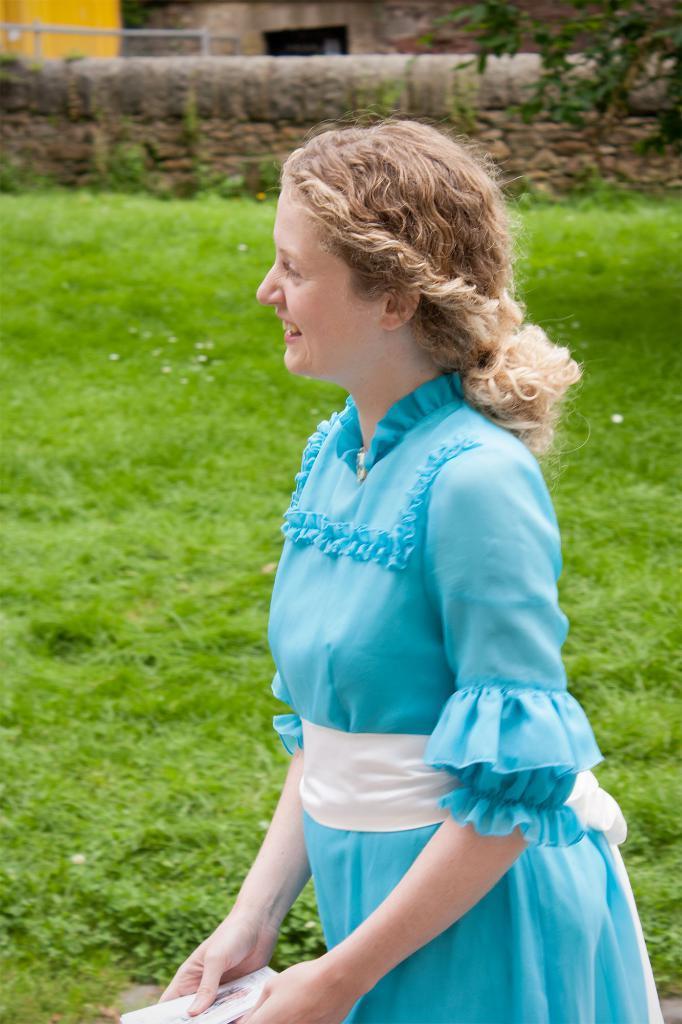Can you describe this image briefly? In this image we can see a woman wearing blue color dress and holding an object, also we can see the wall, grass, trees and a house. 